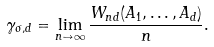Convert formula to latex. <formula><loc_0><loc_0><loc_500><loc_500>\gamma _ { \sigma , d } = \lim _ { n \to \infty } \frac { W _ { n d } ( A _ { 1 } , \dots , A _ { d } ) } { n } .</formula> 